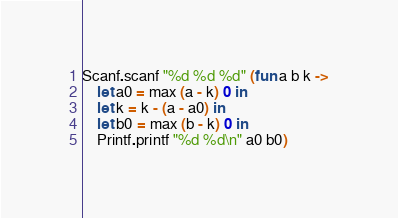<code> <loc_0><loc_0><loc_500><loc_500><_OCaml_>Scanf.scanf "%d %d %d" (fun a b k ->
    let a0 = max (a - k) 0 in
    let k = k - (a - a0) in
    let b0 = max (b - k) 0 in
    Printf.printf "%d %d\n" a0 b0)</code> 